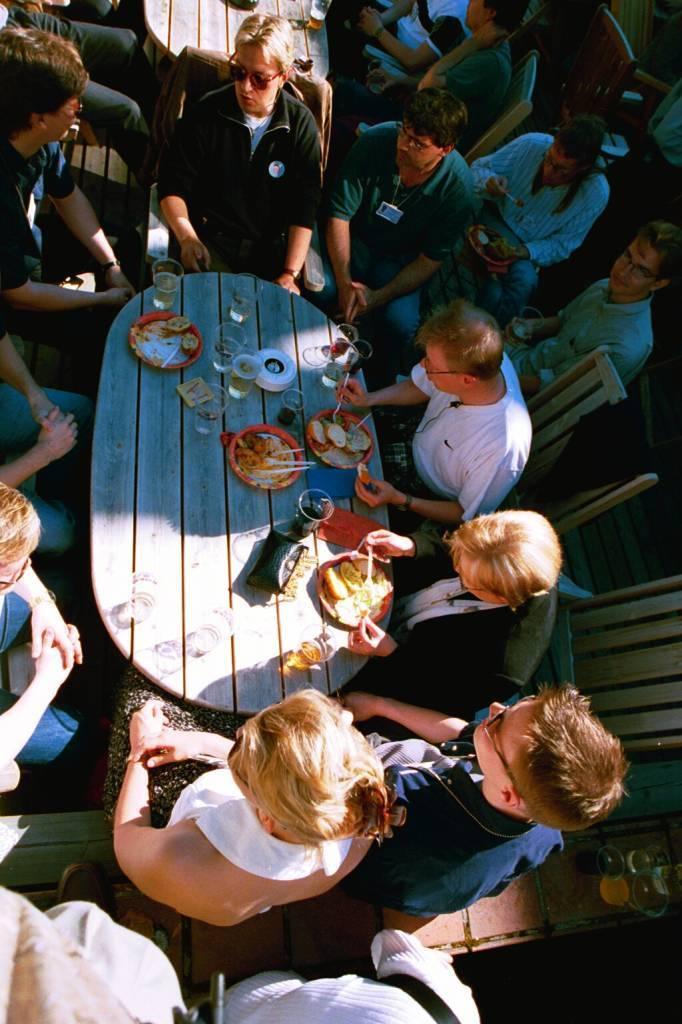How would you summarize this image in a sentence or two? Here in this picture we can see number of people sitting on chairs with table in between them having some food items in plates and some drinks present and this is a top view. 